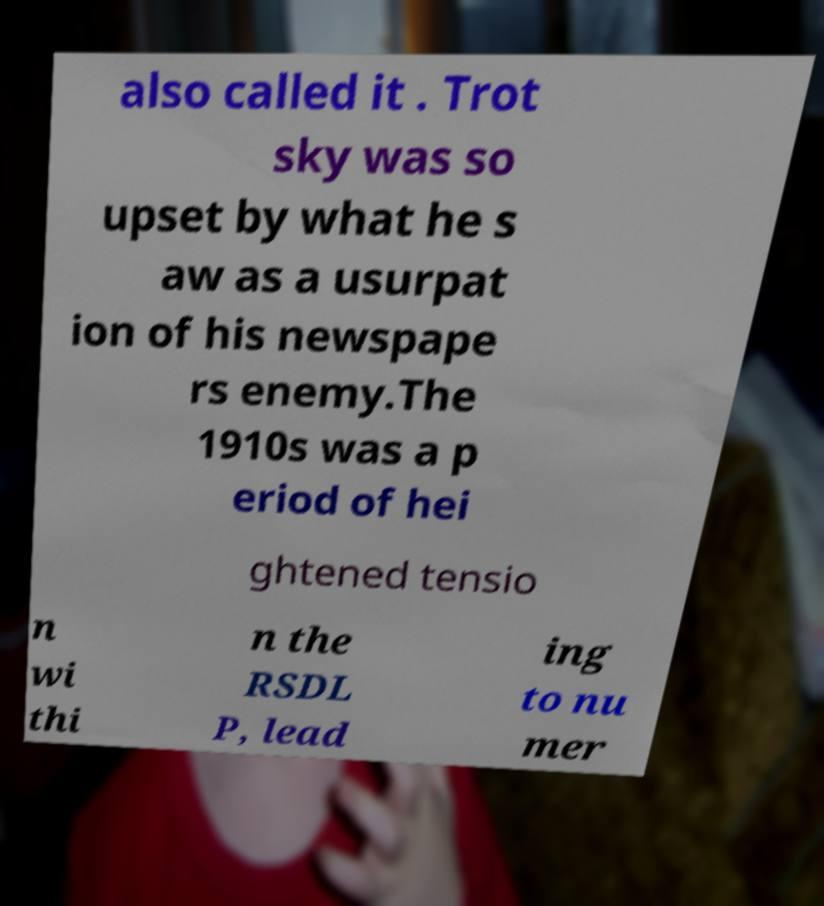What messages or text are displayed in this image? I need them in a readable, typed format. also called it . Trot sky was so upset by what he s aw as a usurpat ion of his newspape rs enemy.The 1910s was a p eriod of hei ghtened tensio n wi thi n the RSDL P, lead ing to nu mer 